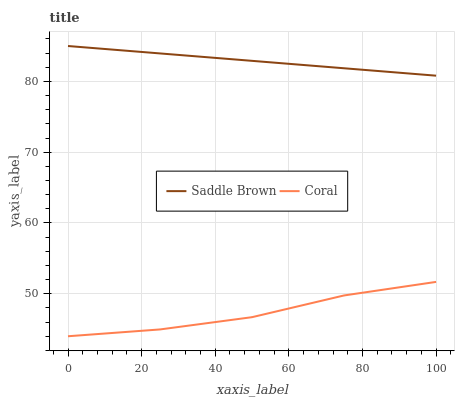Does Coral have the minimum area under the curve?
Answer yes or no. Yes. Does Saddle Brown have the maximum area under the curve?
Answer yes or no. Yes. Does Saddle Brown have the minimum area under the curve?
Answer yes or no. No. Is Saddle Brown the smoothest?
Answer yes or no. Yes. Is Coral the roughest?
Answer yes or no. Yes. Is Saddle Brown the roughest?
Answer yes or no. No. Does Coral have the lowest value?
Answer yes or no. Yes. Does Saddle Brown have the lowest value?
Answer yes or no. No. Does Saddle Brown have the highest value?
Answer yes or no. Yes. Is Coral less than Saddle Brown?
Answer yes or no. Yes. Is Saddle Brown greater than Coral?
Answer yes or no. Yes. Does Coral intersect Saddle Brown?
Answer yes or no. No. 